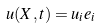Convert formula to latex. <formula><loc_0><loc_0><loc_500><loc_500>\ u ( X , t ) = u _ { i } e _ { i }</formula> 